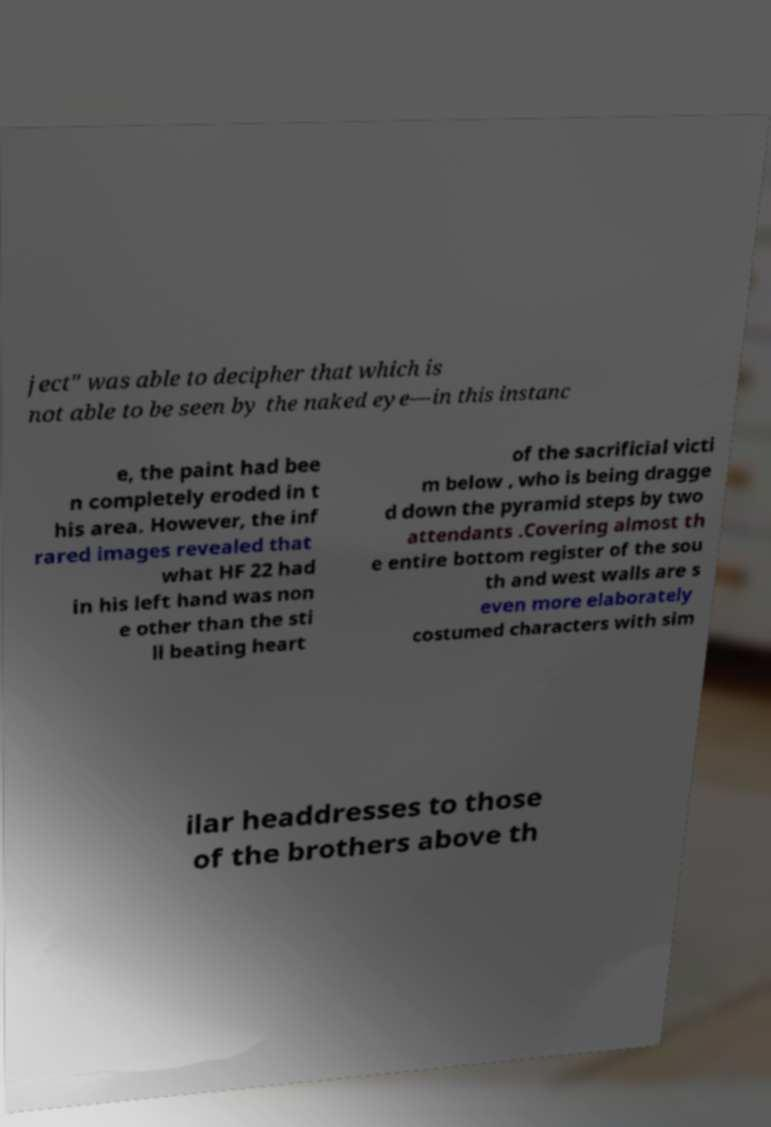Could you assist in decoding the text presented in this image and type it out clearly? ject" was able to decipher that which is not able to be seen by the naked eye—in this instanc e, the paint had bee n completely eroded in t his area. However, the inf rared images revealed that what HF 22 had in his left hand was non e other than the sti ll beating heart of the sacrificial victi m below , who is being dragge d down the pyramid steps by two attendants .Covering almost th e entire bottom register of the sou th and west walls are s even more elaborately costumed characters with sim ilar headdresses to those of the brothers above th 